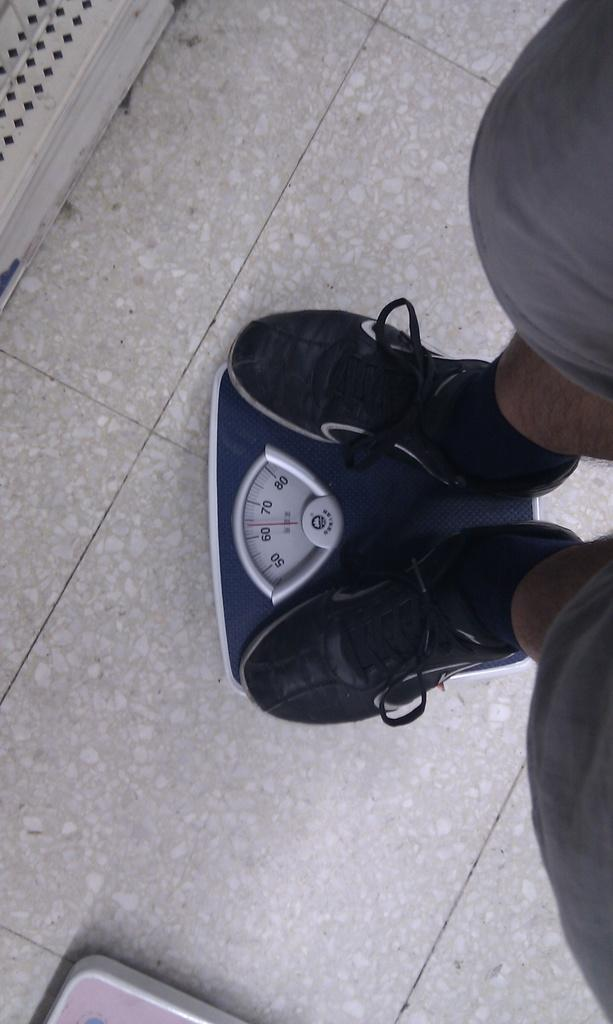What is the person in the image doing? The person is standing on a weighing machine in the image. What can be observed about the person's shoes? The person is wearing black color shoes. What is the color of the floor in the image? The floor is in cream color. What type of crime is being committed in the image? There is no crime being committed in the image; it simply shows a person standing on a weighing machine. How many flags are visible in the image? There are no flags present in the image. 